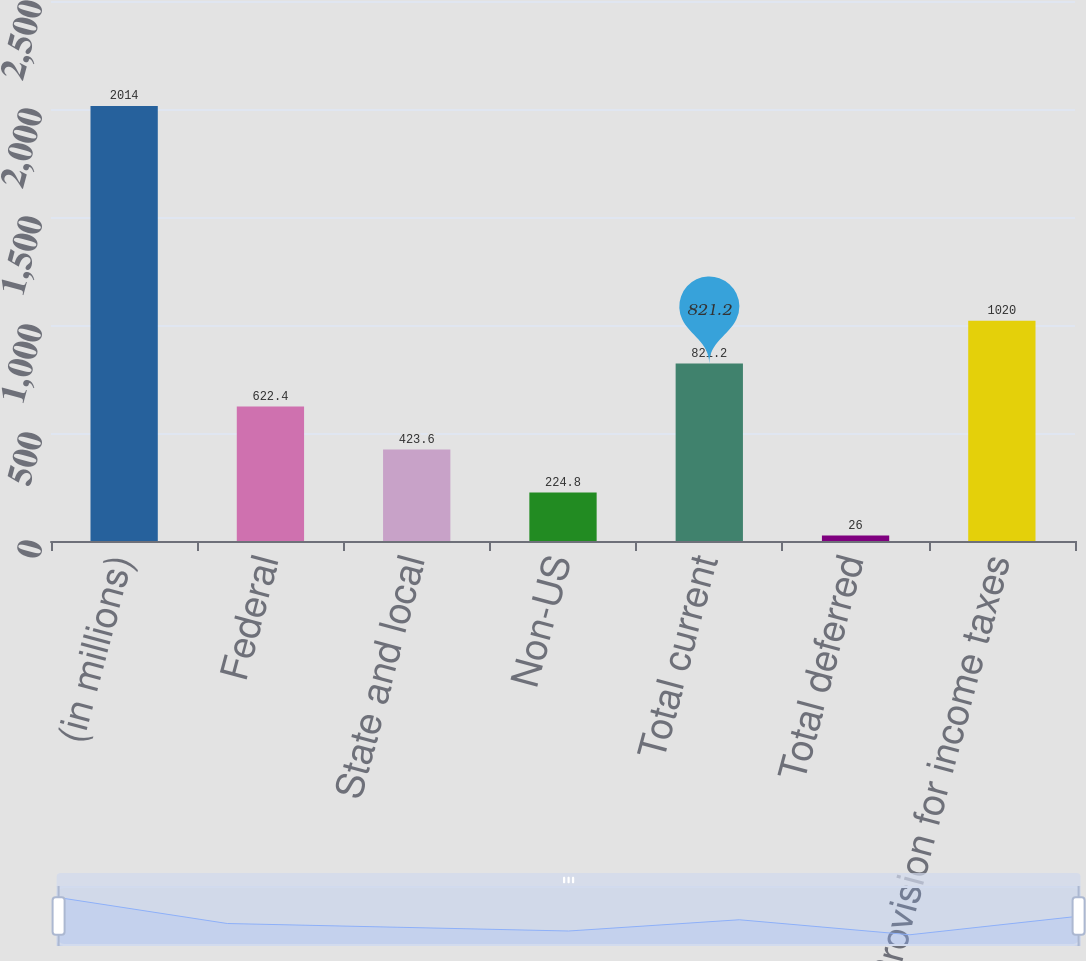<chart> <loc_0><loc_0><loc_500><loc_500><bar_chart><fcel>(in millions)<fcel>Federal<fcel>State and local<fcel>Non-US<fcel>Total current<fcel>Total deferred<fcel>Provision for income taxes<nl><fcel>2014<fcel>622.4<fcel>423.6<fcel>224.8<fcel>821.2<fcel>26<fcel>1020<nl></chart> 